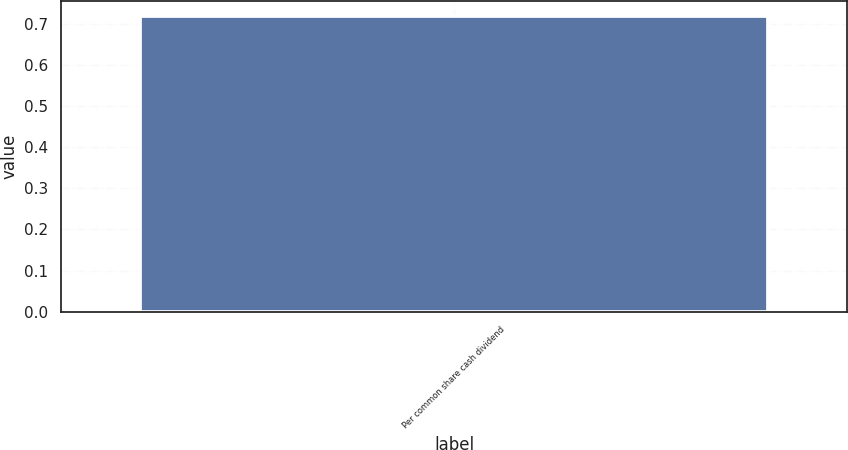Convert chart. <chart><loc_0><loc_0><loc_500><loc_500><bar_chart><fcel>Per common share cash dividend<nl><fcel>0.72<nl></chart> 